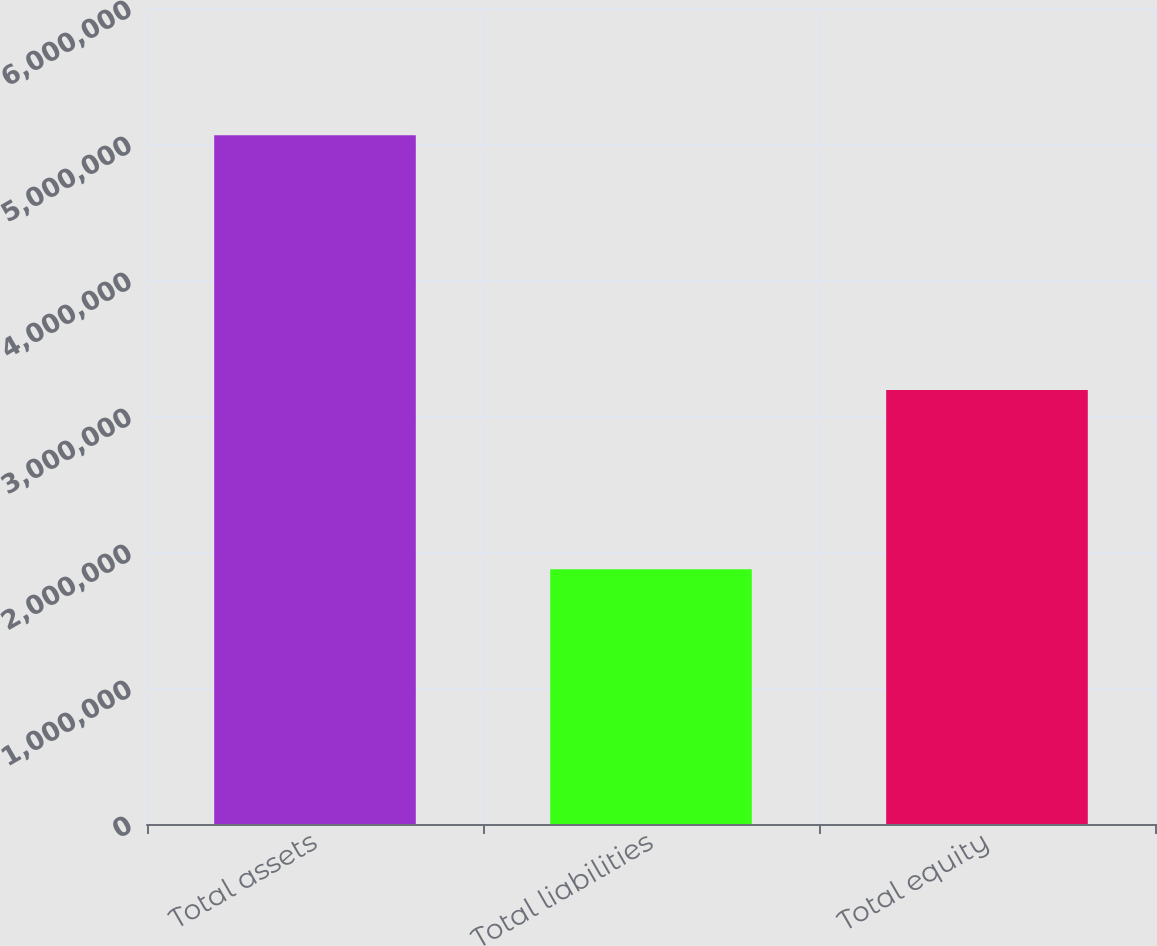Convert chart. <chart><loc_0><loc_0><loc_500><loc_500><bar_chart><fcel>Total assets<fcel>Total liabilities<fcel>Total equity<nl><fcel>5.06464e+06<fcel>1.87282e+06<fcel>3.19182e+06<nl></chart> 